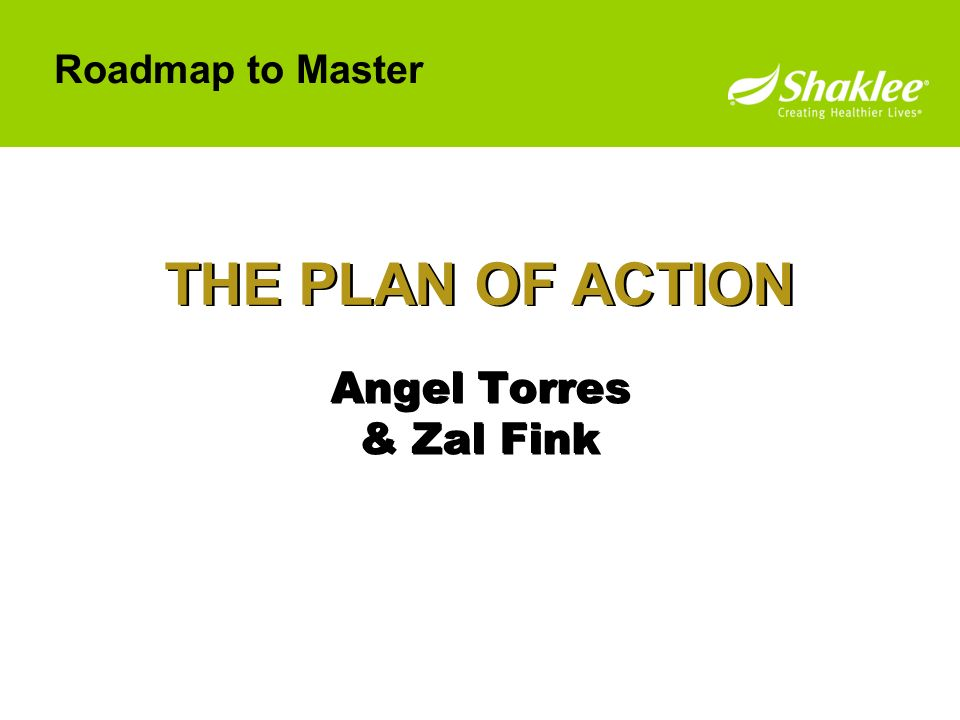If this slide were part of a historical documentary presentation, what would it be about? In the context of a historical documentary presentation, this slide might introduce a significant initiative undertaken during a crucial period in history. 'THE PLAN OF ACTION' could detail a strategic plan developed by notable historical figures, such as 'Angel Torres & Zal Fink,' who might represent leaders or experts instrumental in implementing a historical project or movement. The documentary could focus on their roles and contributions to a pivotal strategy that led to significant historical outcomes, narrating their challenges, decisions, and the plan's impact on subsequent events. This segment would aim to bring historical strategies to life, showcasing the meticulous planning and action that shaped history. 